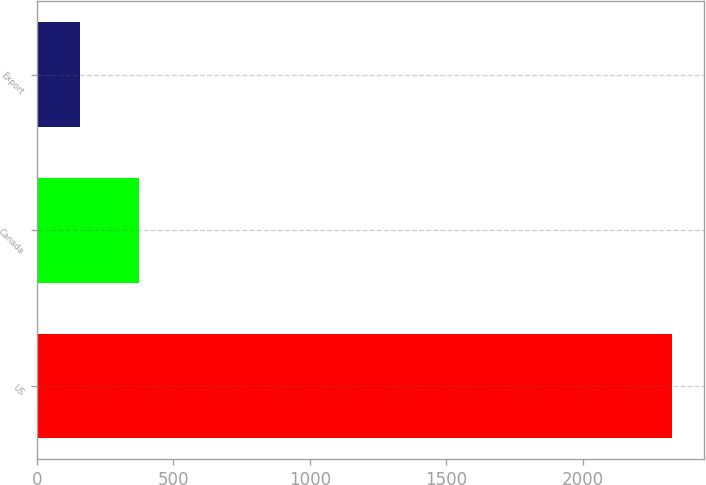Convert chart to OTSL. <chart><loc_0><loc_0><loc_500><loc_500><bar_chart><fcel>US<fcel>Canada<fcel>Export<nl><fcel>2328.1<fcel>373.48<fcel>156.3<nl></chart> 